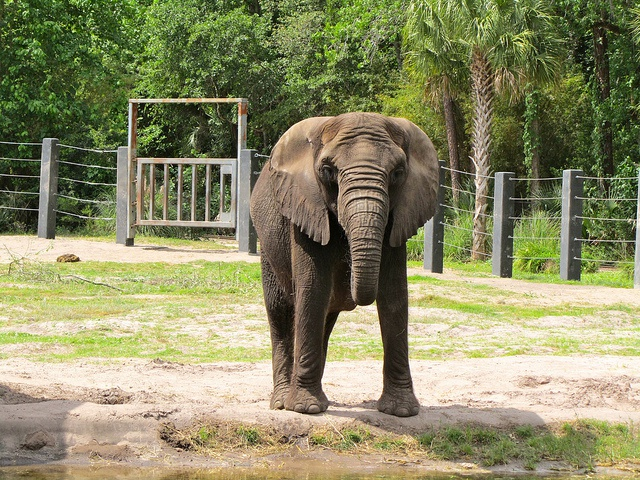Describe the objects in this image and their specific colors. I can see a elephant in darkgreen, black, gray, and tan tones in this image. 